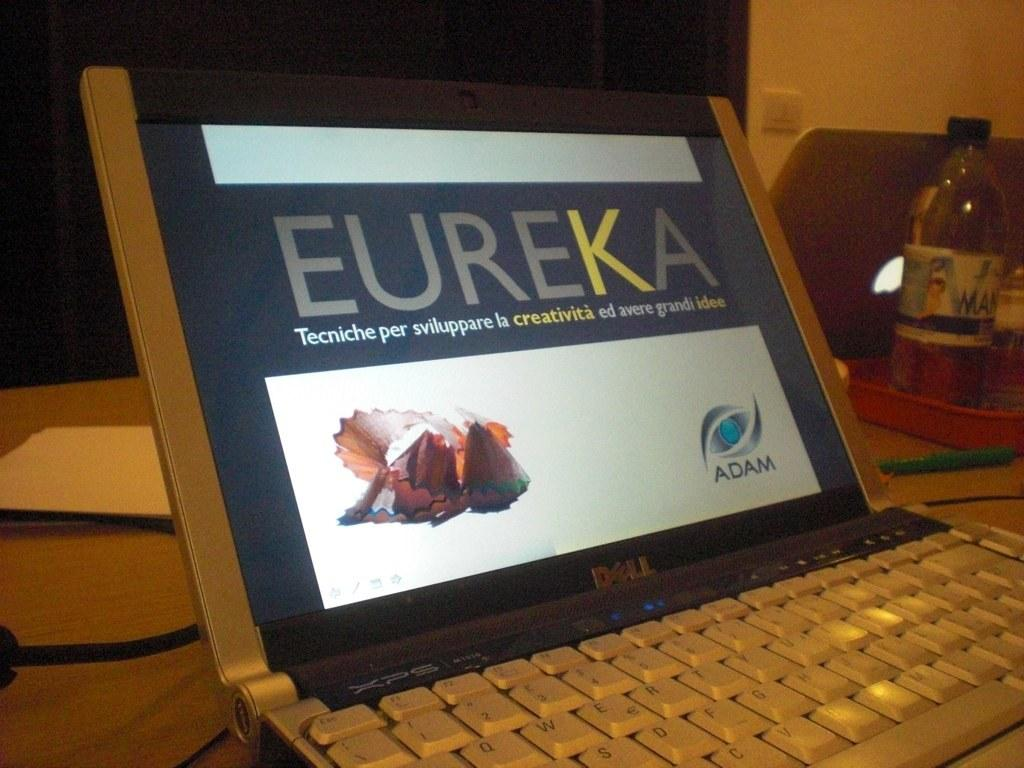Provide a one-sentence caption for the provided image. A small laptop with the words Eureka in bold on the screen. 